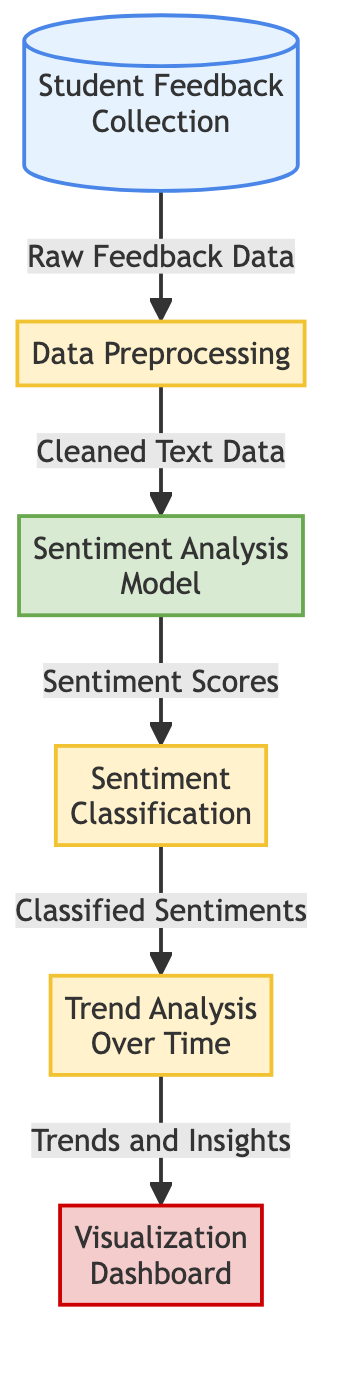What is the first step in the process? The first step in the diagram is "Student Feedback Collection," which indicates that the process begins with gathering feedback from students.
Answer: Student Feedback Collection How many processes are shown in the diagram? There are four process nodes represented in the diagram: "Data Preprocessing," "Sentiment Classification," "Trend Analysis Over Time," and "Visualization Dashboard."
Answer: Four What type of data is outputted from the "Sentiment Analysis Model"? The output of the "Sentiment Analysis Model" is "Sentiment Scores," which represent the numerical evaluation of sentiments derived from processed feedback.
Answer: Sentiment Scores What follows "Data Preprocessing" in the flow? After "Data Preprocessing," the process flows to the "Sentiment Analysis Model," indicating that cleaned text data is then analyzed for sentiment.
Answer: Sentiment Analysis Model How many edges are there in total connecting the nodes? There are five edges in the diagram; each edge represents a connection or flow of data between two nodes.
Answer: Five What is the final output of the entire process? The final output of the process is "Visualization Dashboard," which is the result of analyzing trends and insights based on classified sentiments.
Answer: Visualization Dashboard Which node receives the output from "Sentiment Classification"? The "Trend Analysis Over Time" node receives its input from the "Sentiment Classification" node, indicating it uses the classified sentiments for trend analysis.
Answer: Trend Analysis Over Time Which two nodes are connected by an edge indicating a flow of data? The "Sentiment Analysis Model" and "Sentiment Classification" nodes are directly connected by an edge, showing the flow from sentiment analysis to classification.
Answer: Sentiment Analysis Model and Sentiment Classification What does the "Visualization Dashboard" provide? The "Visualization Dashboard" provides visual representations of the trends and insights derived from the earlier sentiment analysis and classification processes.
Answer: Trends and Insights 